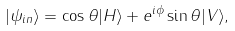Convert formula to latex. <formula><loc_0><loc_0><loc_500><loc_500>| \psi _ { i n } \rangle = \cos \theta | H \rangle + e ^ { i \phi } \sin \theta | V \rangle ,</formula> 